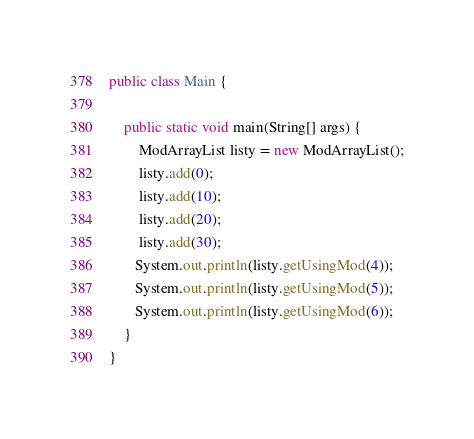Convert code to text. <code><loc_0><loc_0><loc_500><loc_500><_Java_>public class Main {

    public static void main(String[] args) {
        ModArrayList listy = new ModArrayList();
        listy.add(0);
        listy.add(10);
        listy.add(20);
        listy.add(30);
       System.out.println(listy.getUsingMod(4));
       System.out.println(listy.getUsingMod(5));
       System.out.println(listy.getUsingMod(6));
    }
}
</code> 